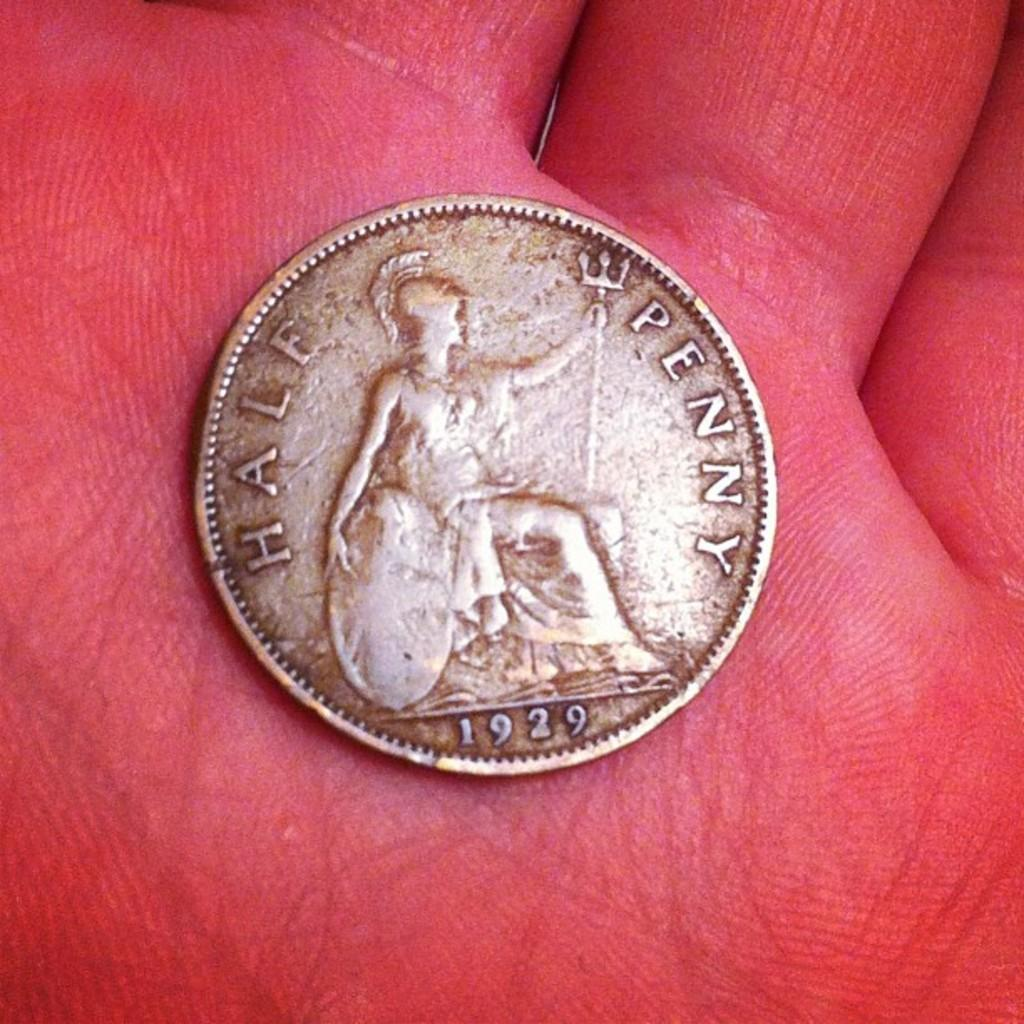What object is being held by the person in the image? There is a coin in the person's hand. What can be observed about the color of the person's hand? The person's hand is red in color. What type of button is being pressed by the person in the image? There is no button present in the image; the person is holding a coin. What type of tank is visible in the background of the image? There is no tank visible in the image; the focus is on the person's hand and the coin. 